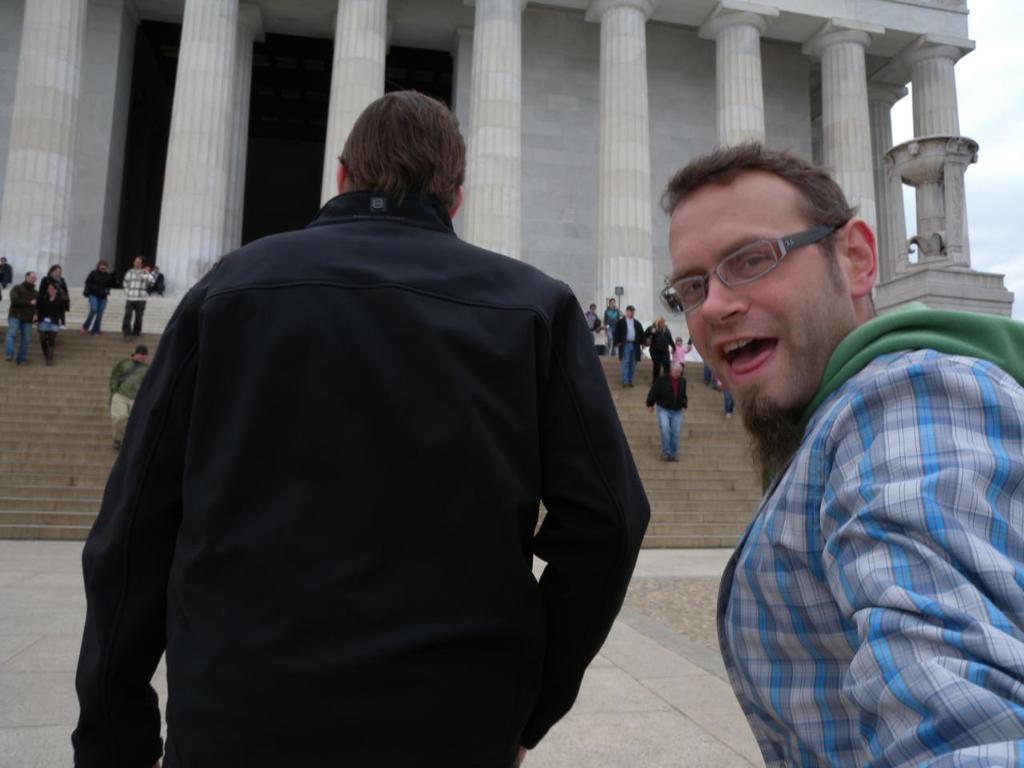Can you describe this image briefly? In the image there is a person in black dress standing in the middle and another person in blue checks shirt standing on the right side and in the back there is a palace with many people walking in front of it on the steps, on the right side top its sky with clouds. 